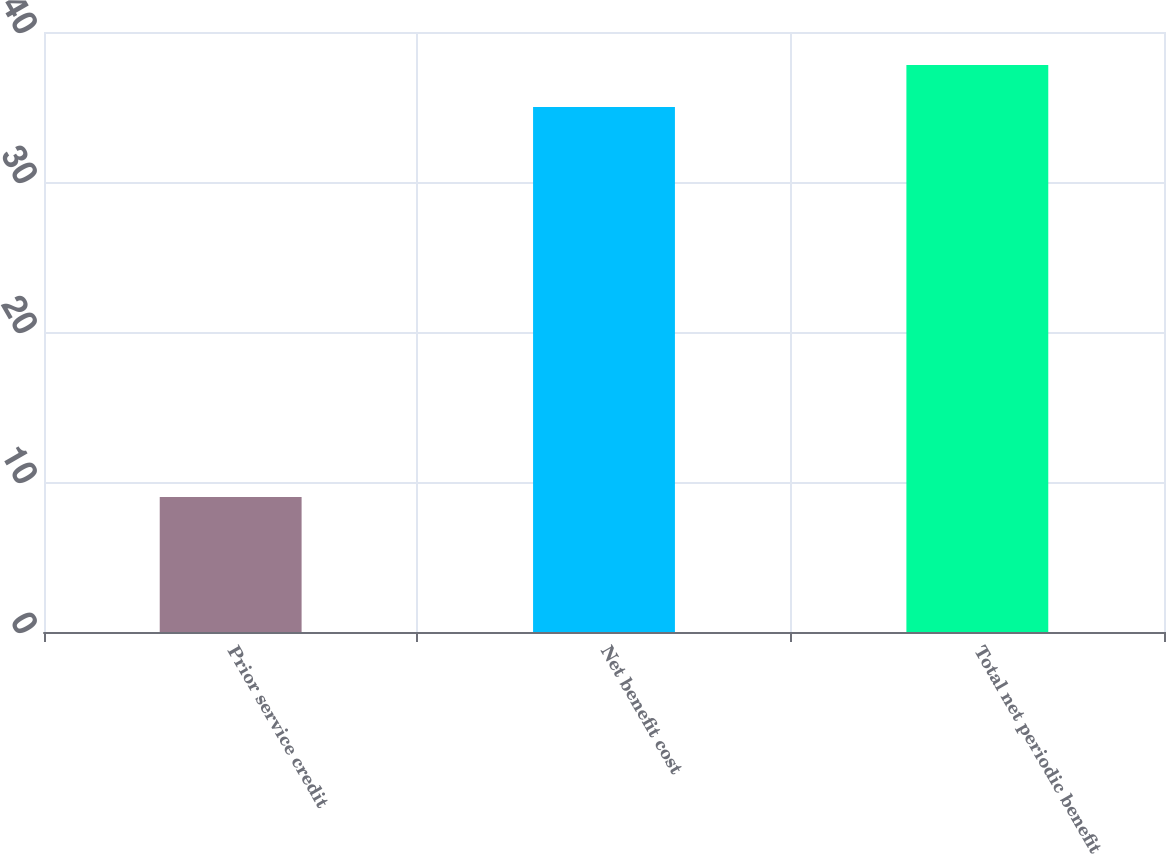Convert chart to OTSL. <chart><loc_0><loc_0><loc_500><loc_500><bar_chart><fcel>Prior service credit<fcel>Net benefit cost<fcel>Total net periodic benefit<nl><fcel>9<fcel>35<fcel>37.8<nl></chart> 